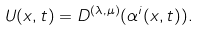<formula> <loc_0><loc_0><loc_500><loc_500>U ( x , t ) = D ^ { ( \lambda , \mu ) } ( \alpha ^ { i } ( x , t ) ) .</formula> 